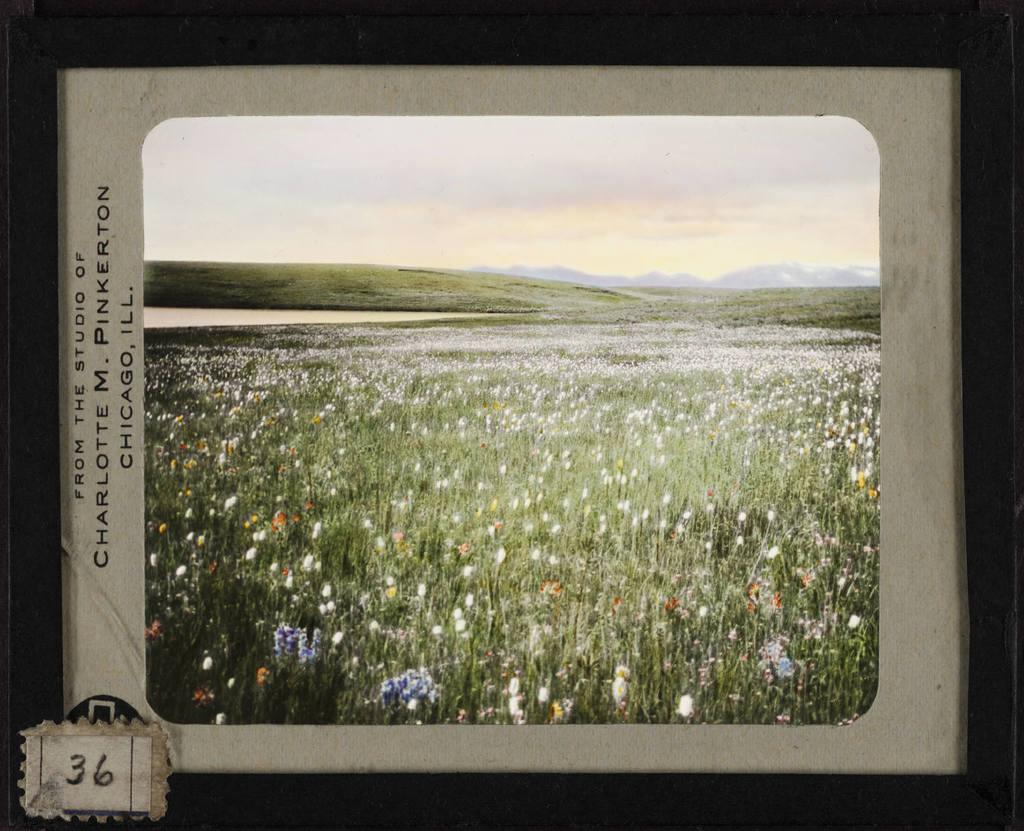<image>
Offer a succinct explanation of the picture presented. Picture of a grass field that says Chicago, IL on the side. 